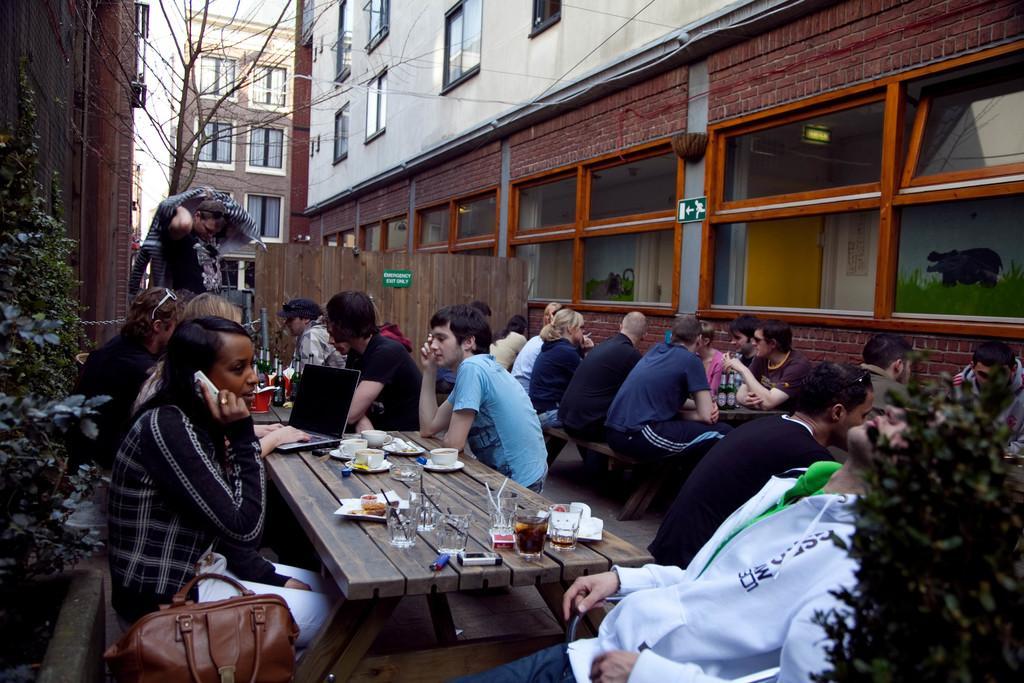Describe this image in one or two sentences. In this image there are group of people sitting on the bench. On the table there is a glass,cup,saucer,laptop. At the background we can see a building there is a plant. On table there is a bag. 